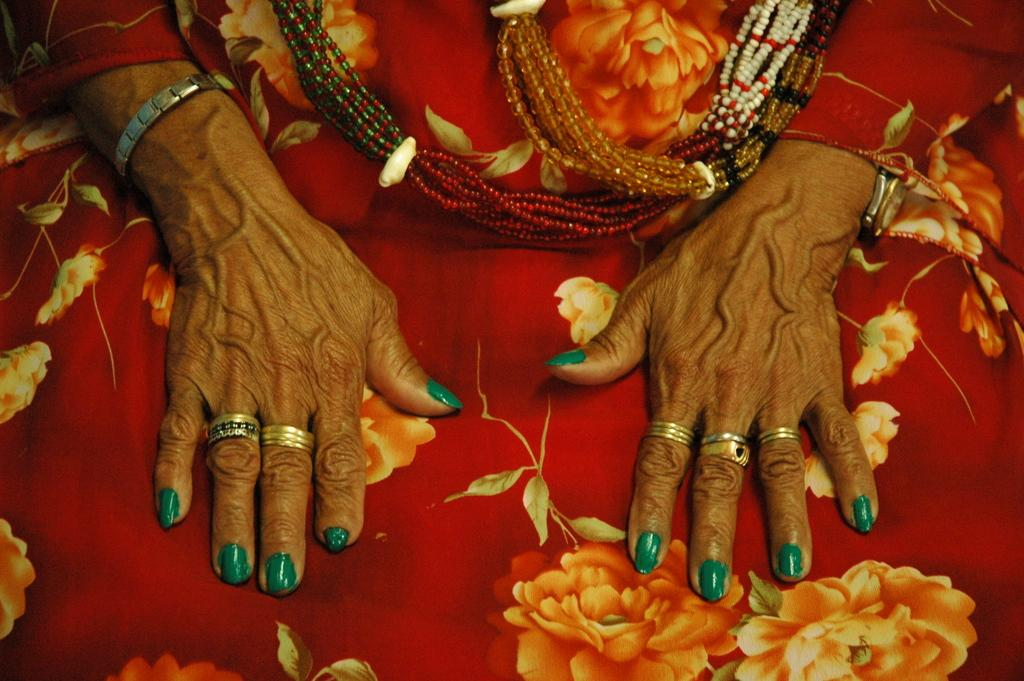What body parts can be seen in the image? There are hands visible in the image. What type of clothing is present in the image? There is a dress in the image. What type of accessory can be seen in the image? There are necklaces in the image. Where is the cap stored in the image? There is no cap present in the image. What type of hill can be seen in the background of the image? There is no hill visible in the image. 